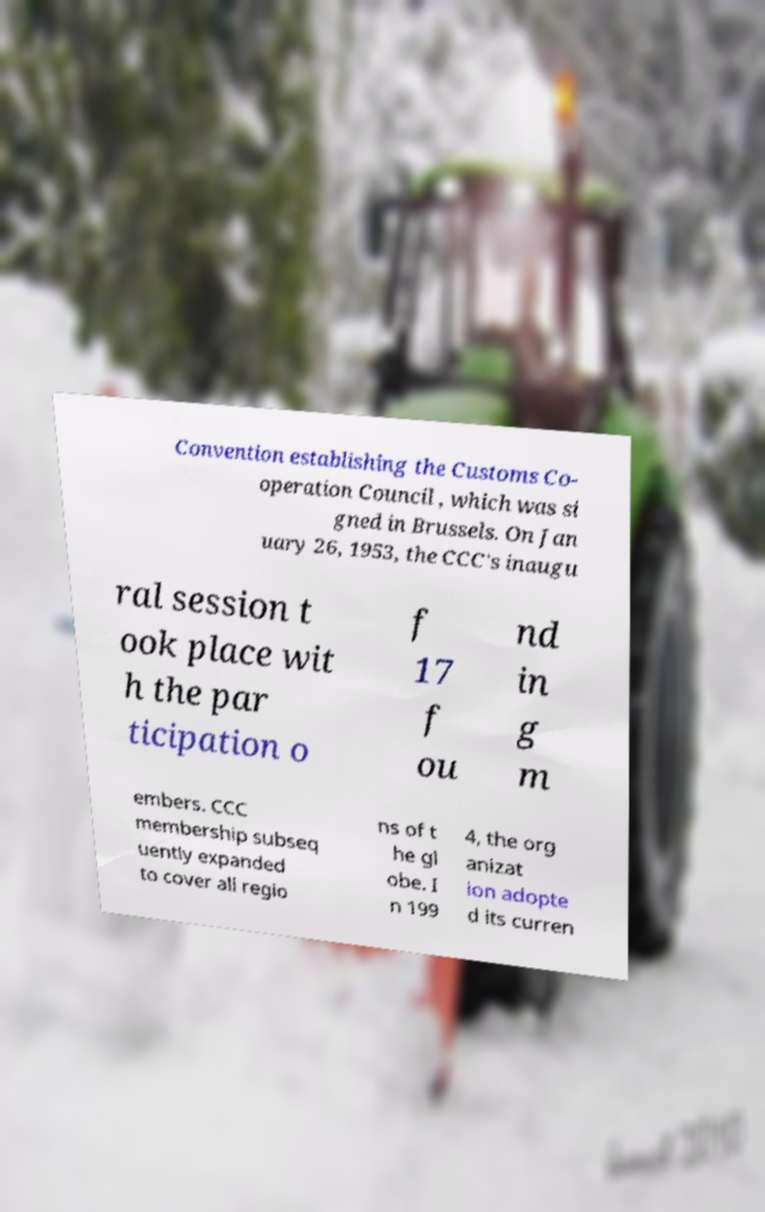I need the written content from this picture converted into text. Can you do that? Convention establishing the Customs Co- operation Council , which was si gned in Brussels. On Jan uary 26, 1953, the CCC's inaugu ral session t ook place wit h the par ticipation o f 17 f ou nd in g m embers. CCC membership subseq uently expanded to cover all regio ns of t he gl obe. I n 199 4, the org anizat ion adopte d its curren 